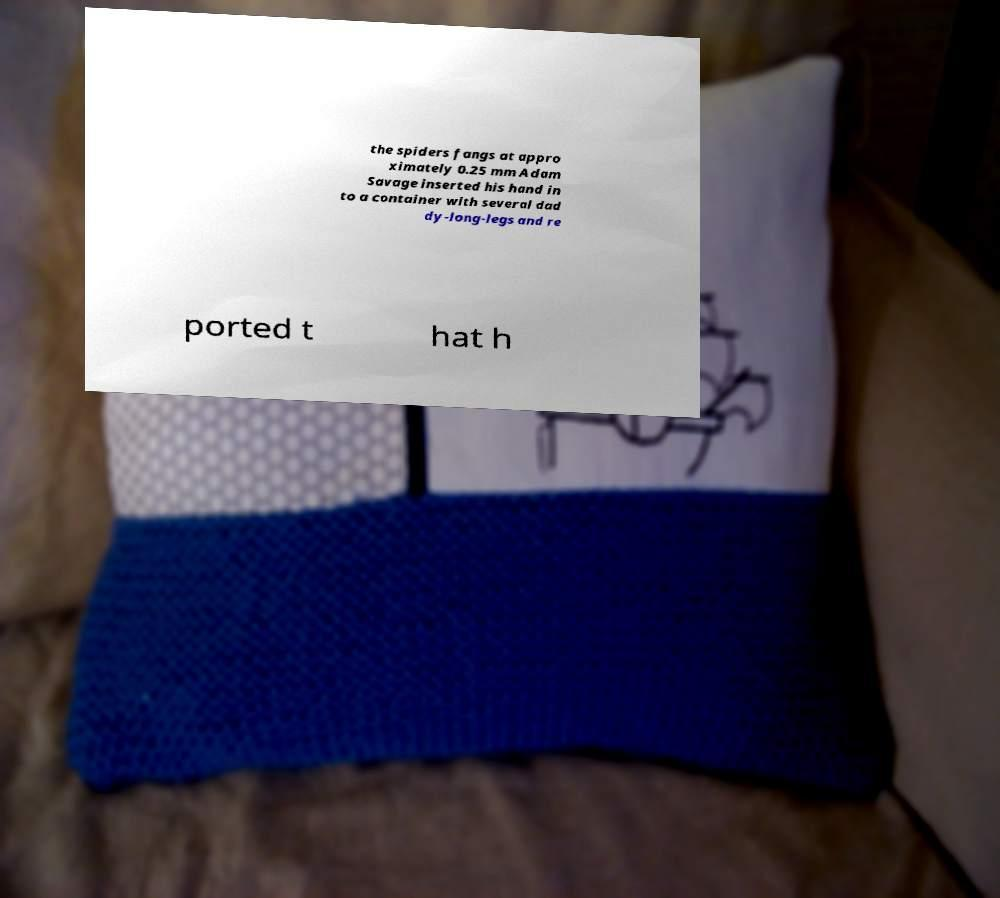I need the written content from this picture converted into text. Can you do that? the spiders fangs at appro ximately 0.25 mm Adam Savage inserted his hand in to a container with several dad dy-long-legs and re ported t hat h 